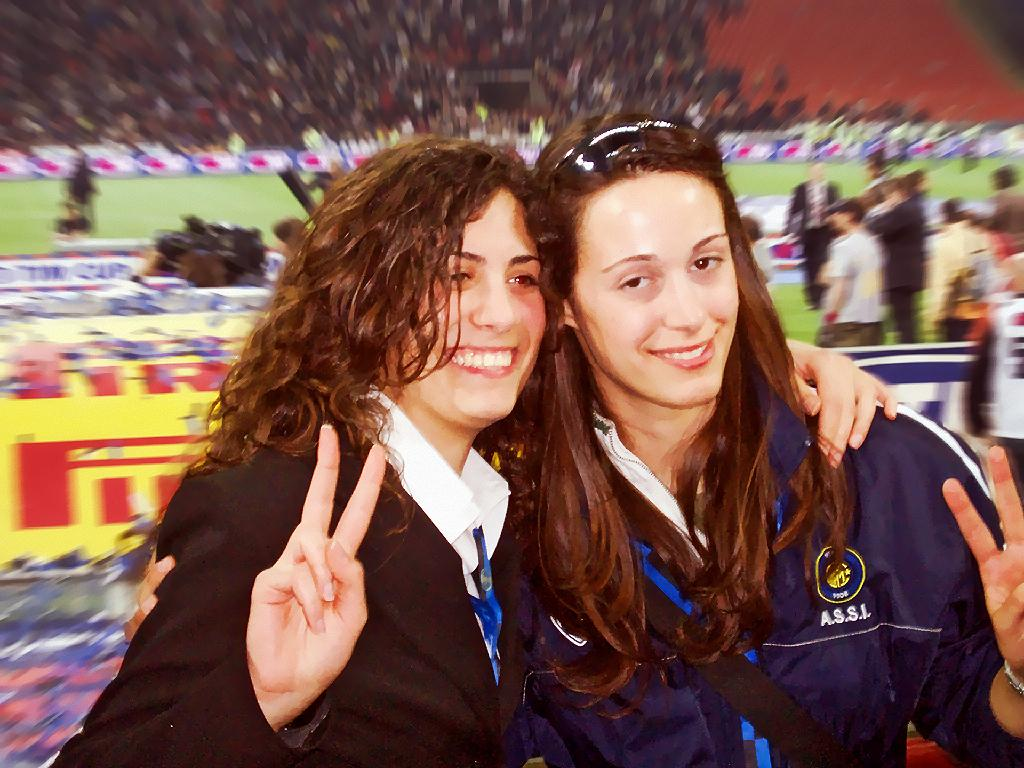How many ladies are in the image? There are two ladies in the image. What are the ladies doing in the image? The ladies are standing and smiling. Can you describe the people behind the ladies? There are other people visible behind the ladies. What else can be seen in the image besides the ladies and the people behind them? There are other things visible in the image. What color is the temper of the kite in the image? There is no kite present in the image, and therefore no temper to describe. 